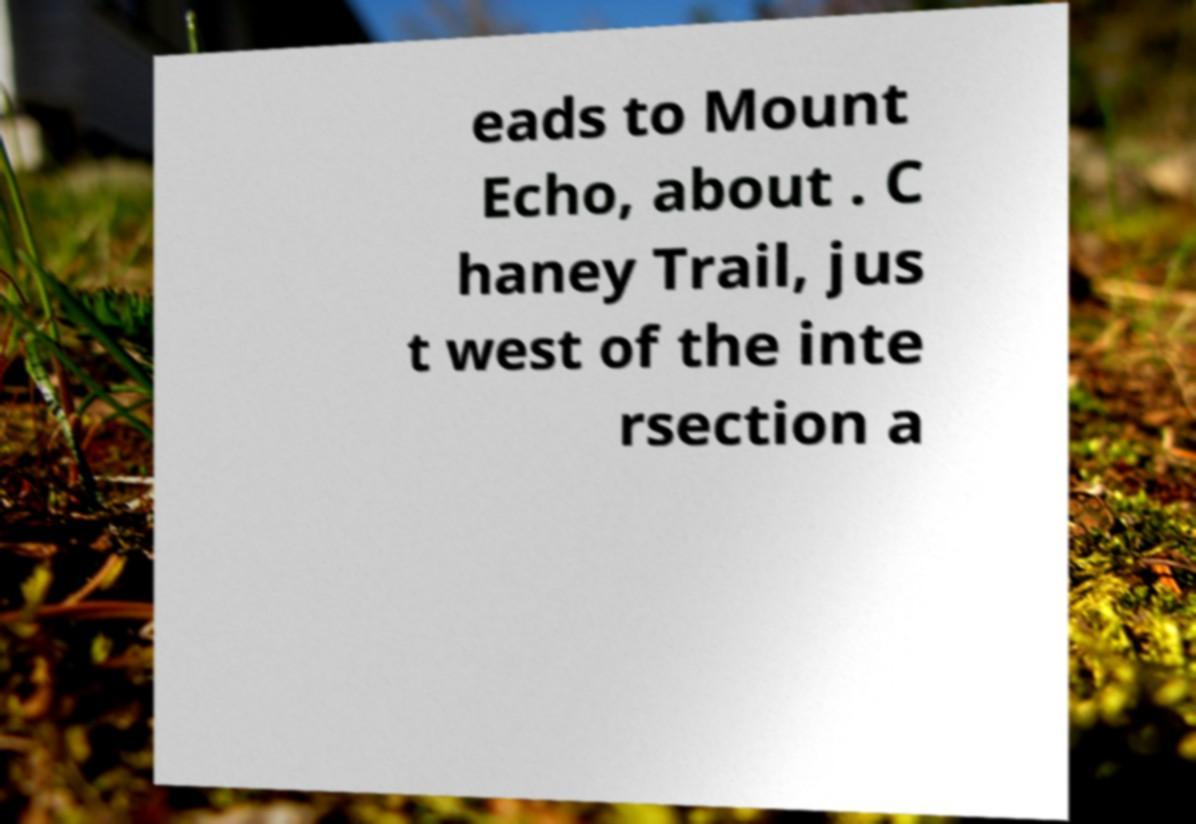Please read and relay the text visible in this image. What does it say? eads to Mount Echo, about . C haney Trail, jus t west of the inte rsection a 